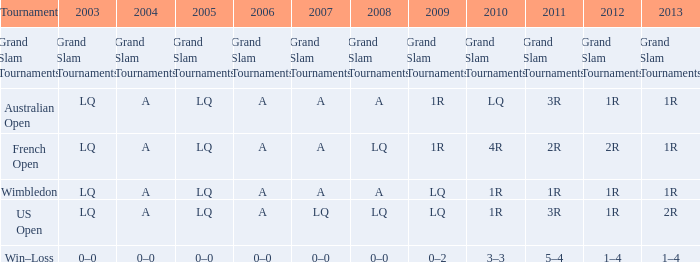Which contest featured a 1r outcome in 2013 and also in 2012? Australian Open, Wimbledon. 